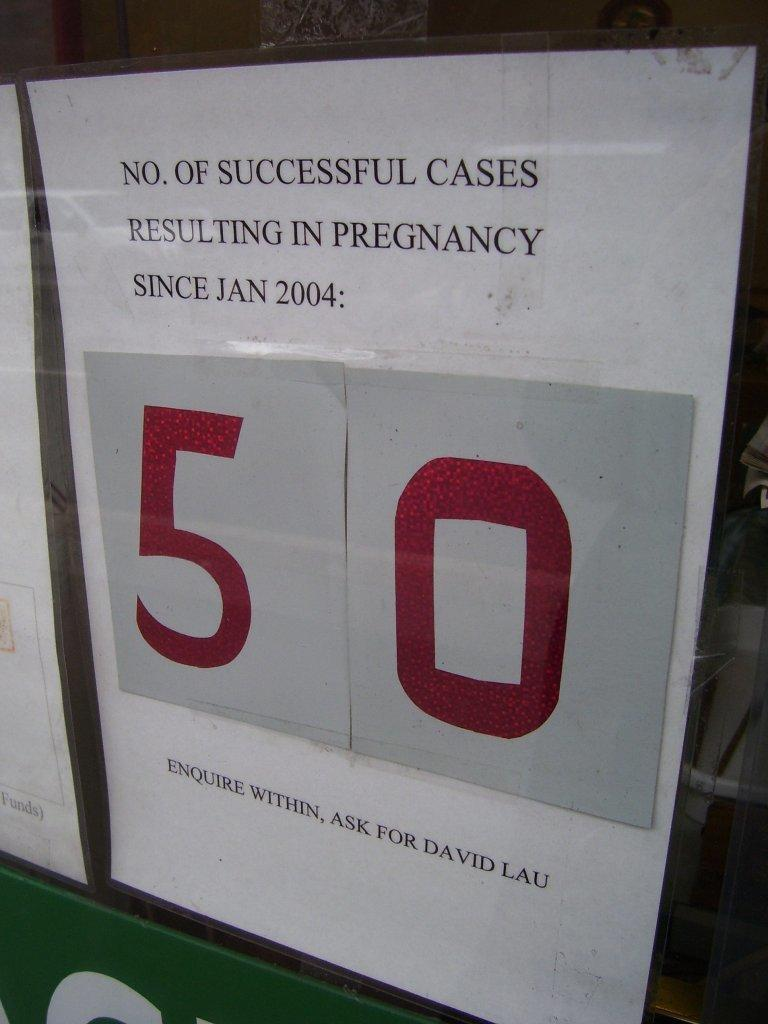<image>
Offer a succinct explanation of the picture presented. A sign counting how many sucessful pregnancies there have been. 